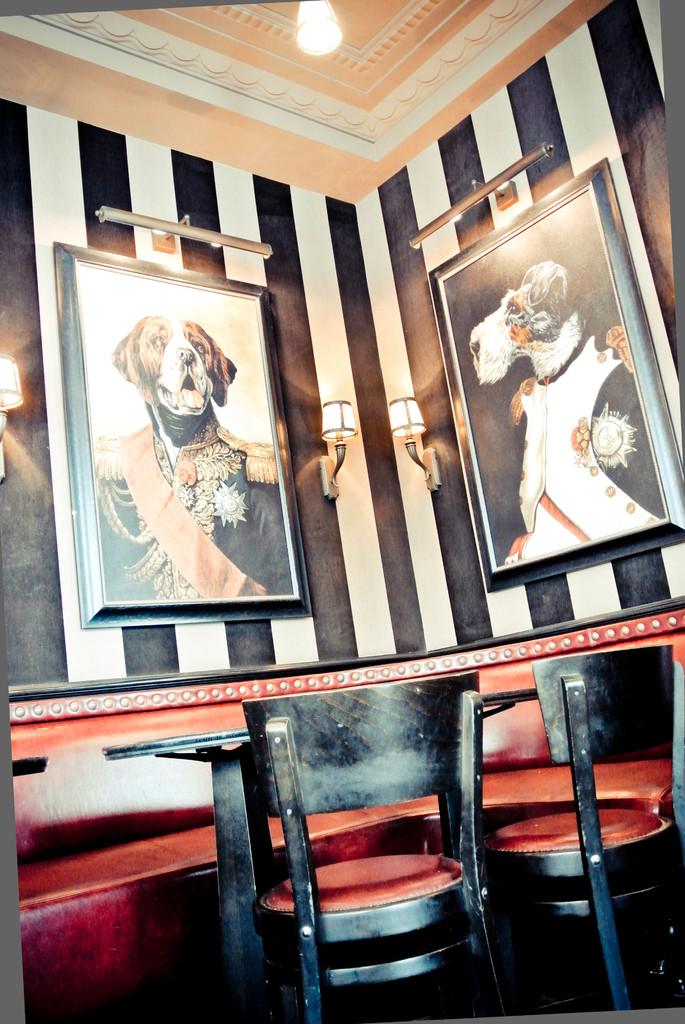What type of furniture can be seen in the image? There are chairs in the image. What is the background of the image made of? There is a wall in the image. What type of decorative items are present in the image? There are frames in the image. What provides illumination in the image? There are lights in the image. Can you see a rock on the back of one of the chairs in the image? There is no rock present on the back of any chair in the image. What type of box is placed on the wall in the image? There is no box present on the wall in the image. 